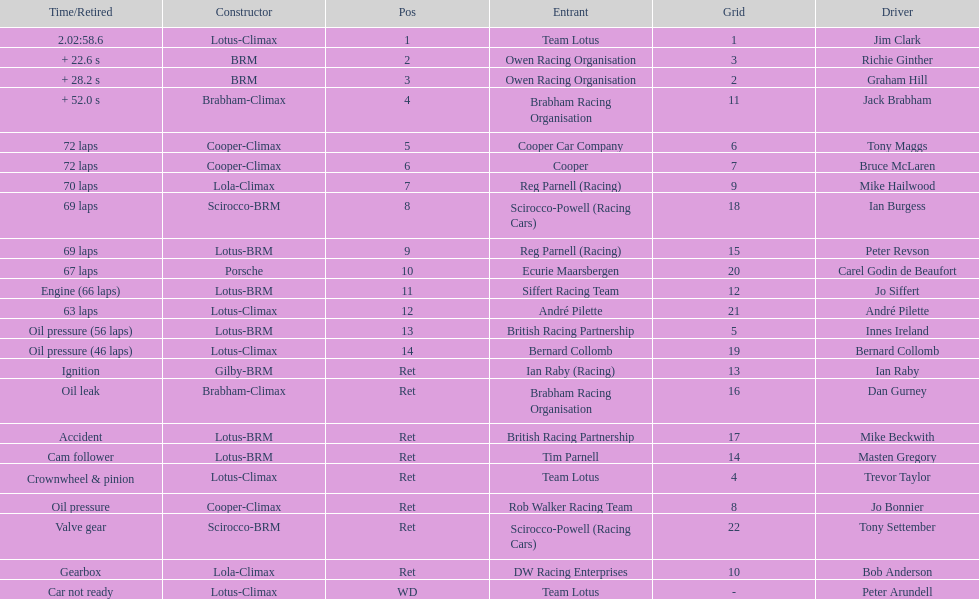What was the same problem that bernard collomb had as innes ireland? Oil pressure. 